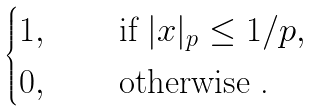<formula> <loc_0><loc_0><loc_500><loc_500>\begin{cases} 1 , & \quad \text { if } | x | _ { p } \leq 1 / p , \\ 0 , & \quad \text { otherwise .} \end{cases}</formula> 